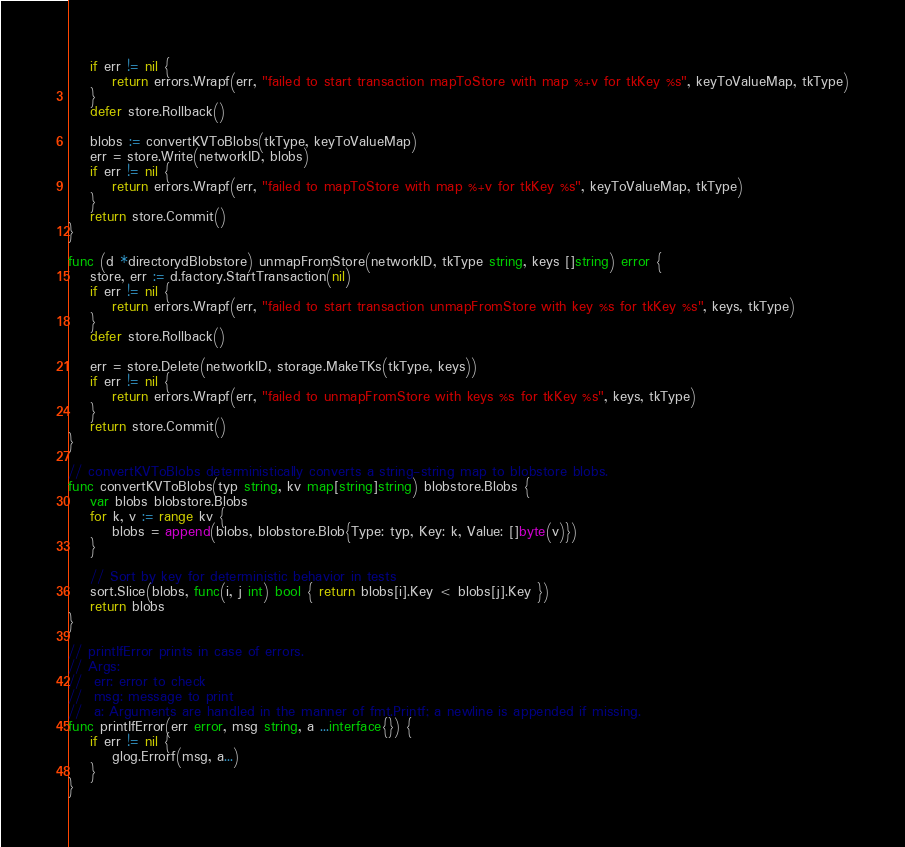Convert code to text. <code><loc_0><loc_0><loc_500><loc_500><_Go_>	if err != nil {
		return errors.Wrapf(err, "failed to start transaction mapToStore with map %+v for tkKey %s", keyToValueMap, tkType)
	}
	defer store.Rollback()

	blobs := convertKVToBlobs(tkType, keyToValueMap)
	err = store.Write(networkID, blobs)
	if err != nil {
		return errors.Wrapf(err, "failed to mapToStore with map %+v for tkKey %s", keyToValueMap, tkType)
	}
	return store.Commit()
}

func (d *directorydBlobstore) unmapFromStore(networkID, tkType string, keys []string) error {
	store, err := d.factory.StartTransaction(nil)
	if err != nil {
		return errors.Wrapf(err, "failed to start transaction unmapFromStore with key %s for tkKey %s", keys, tkType)
	}
	defer store.Rollback()

	err = store.Delete(networkID, storage.MakeTKs(tkType, keys))
	if err != nil {
		return errors.Wrapf(err, "failed to unmapFromStore with keys %s for tkKey %s", keys, tkType)
	}
	return store.Commit()
}

// convertKVToBlobs deterministically converts a string-string map to blobstore blobs.
func convertKVToBlobs(typ string, kv map[string]string) blobstore.Blobs {
	var blobs blobstore.Blobs
	for k, v := range kv {
		blobs = append(blobs, blobstore.Blob{Type: typ, Key: k, Value: []byte(v)})
	}

	// Sort by key for deterministic behavior in tests
	sort.Slice(blobs, func(i, j int) bool { return blobs[i].Key < blobs[j].Key })
	return blobs
}

// printIfError prints in case of errors.
// Args:
// 	err: error to check
//  msg: message to print
//  a: Arguments are handled in the manner of fmt.Printf; a newline is appended if missing.
func printIfError(err error, msg string, a ...interface{}) {
	if err != nil {
		glog.Errorf(msg, a...)
	}
}
</code> 